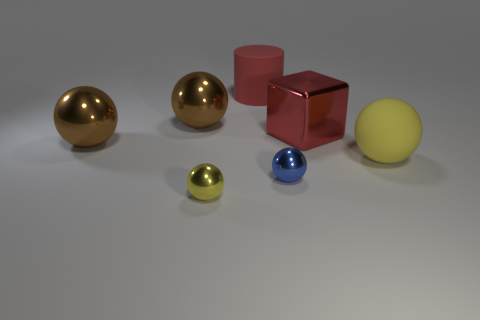Is the material of the small ball that is left of the red rubber cylinder the same as the large cube left of the matte sphere?
Your response must be concise. Yes. Are there an equal number of metallic balls that are right of the large yellow thing and big brown shiny objects that are right of the large red cylinder?
Your answer should be very brief. Yes. There is a tiny blue ball to the right of the tiny yellow object; what is it made of?
Your answer should be very brief. Metal. Are there any other things that are the same size as the red metal thing?
Offer a very short reply. Yes. Is the number of small blue metal balls less than the number of big metallic things?
Your response must be concise. Yes. What shape is the large object that is behind the big red metallic thing and in front of the red matte thing?
Offer a terse response. Sphere. What number of big red shiny cubes are there?
Keep it short and to the point. 1. The large red object that is in front of the rubber thing behind the yellow thing right of the large red metallic block is made of what material?
Your response must be concise. Metal. There is a big rubber object that is left of the matte sphere; what number of metal things are to the left of it?
Your response must be concise. 3. The other tiny thing that is the same shape as the blue object is what color?
Keep it short and to the point. Yellow. 